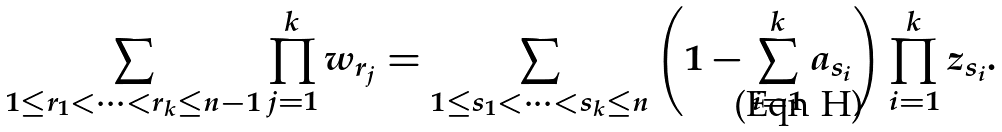<formula> <loc_0><loc_0><loc_500><loc_500>\sum _ { 1 \leq r _ { 1 } < \dots < r _ { k } \leq n - 1 } \prod _ { j = 1 } ^ { k } w _ { r _ { j } } = \sum _ { 1 \leq s _ { 1 } < \dots < s _ { k } \leq n } \left ( 1 - \sum _ { i = 1 } ^ { k } a _ { s _ { i } } \right ) \prod _ { i = 1 } ^ { k } z _ { s _ { i } } .</formula> 